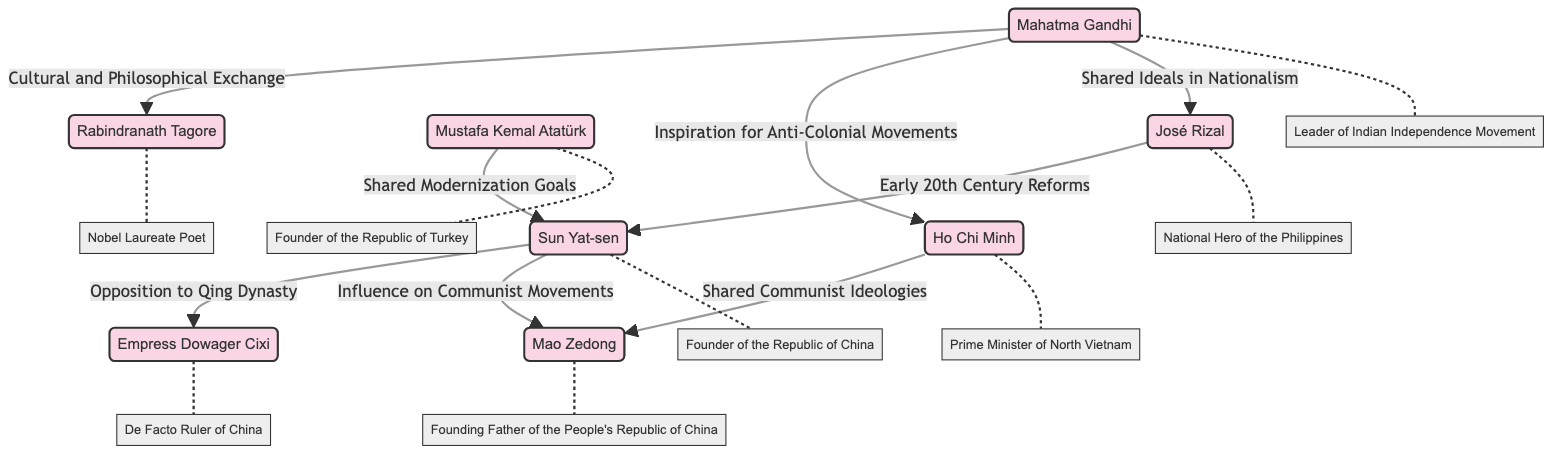What is the total number of nodes in the diagram? Count the unique nodes listed in the "nodes" section of the data. There are 8 unique figures shown, which are Sun Yat-sen, Mahatma Gandhi, Ho Chi Minh, Empress Dowager Cixi, Rabindranath Tagore, Mustafa Kemal Atatürk, José Rizal, and Mao Zedong.
Answer: 8 Who is the de facto ruler of China according to the diagram? Look at the node labeled "Empress Dowager Cixi," which states that she is the de facto ruler of China.
Answer: Empress Dowager Cixi What relationship exists between Sun Yat-sen and Mao Zedong? Examine the edge that connects "Sun Yat-sen" to "Mao Zedong." The text on the edge states "Influence on Communist Movements."
Answer: Influence on Communist Movements Which figure is linked to both Ho Chi Minh and Rabindranath Tagore? Review the connections from Mahatma Gandhi, who has edges leading to both "Ho Chi Minh" and "Rabindranath Tagore."
Answer: Mahatma Gandhi How many edges are there in total within the diagram? Count the relationships listed in the "edges" section. There are 8 individual relations connecting various figures.
Answer: 8 What common goal is shared between Sun Yat-sen and Mustafa Kemal Atatürk? Check the edge connecting "Sun Yat-sen" and "Mustafa Kemal Atatürk," which notes "Shared Modernization Goals" as their common aim.
Answer: Shared Modernization Goals Which figure inspired Ho Chi Minh’s anti-colonial movements? Look at the edge connecting Mahatma Gandhi to Ho Chi Minh that states "Inspiration for Anti-Colonial Movements."
Answer: Mahatma Gandhi Name the Nobel Laureate Poet mentioned in the diagram. Identify the node labeled as "Rabindranath Tagore," which indicates that he is a Nobel Laureate Poet.
Answer: Rabindranath Tagore What is the influence of José Rizal according to the network? Review the information associated with José Rizal; he is noted for the "Reformist Movement and Propaganda."
Answer: Reformist Movement and Propaganda 